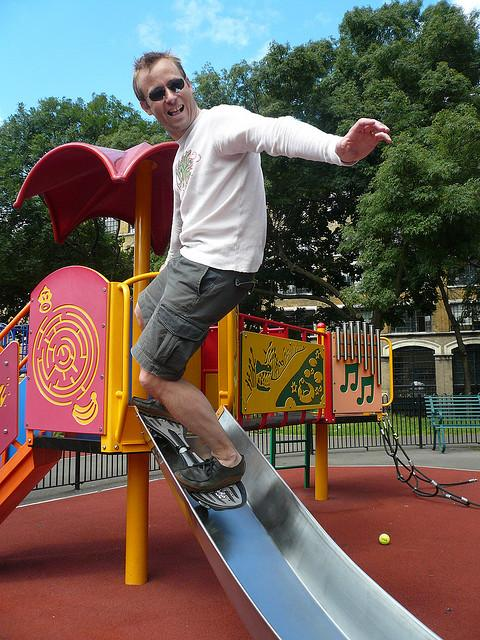The feet of the man are placed on what two wheeled object?

Choices:
A) scooter
B) hoverboard
C) skateboard
D) caster board caster board 